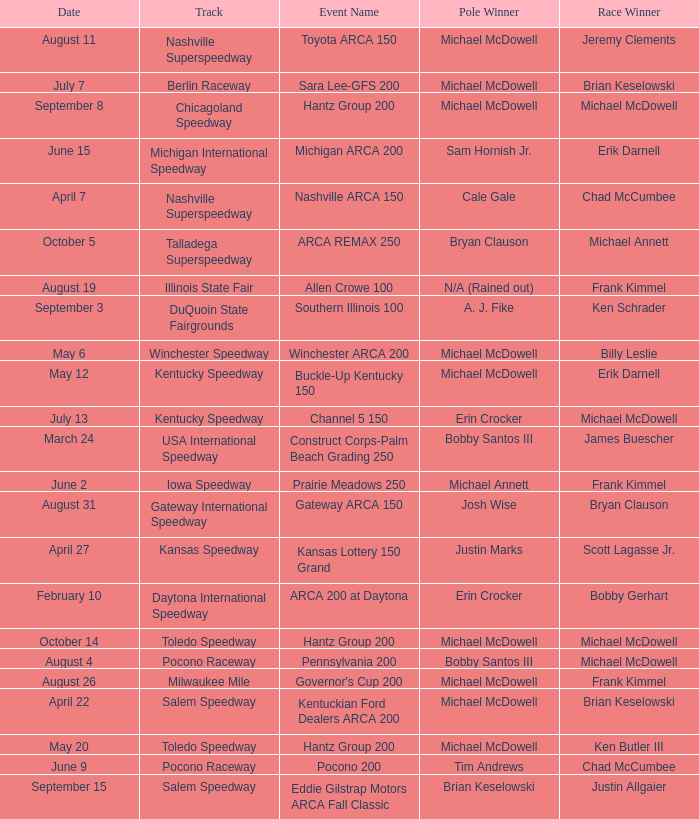Tell me the track for scott lagasse jr. Kansas Speedway. 